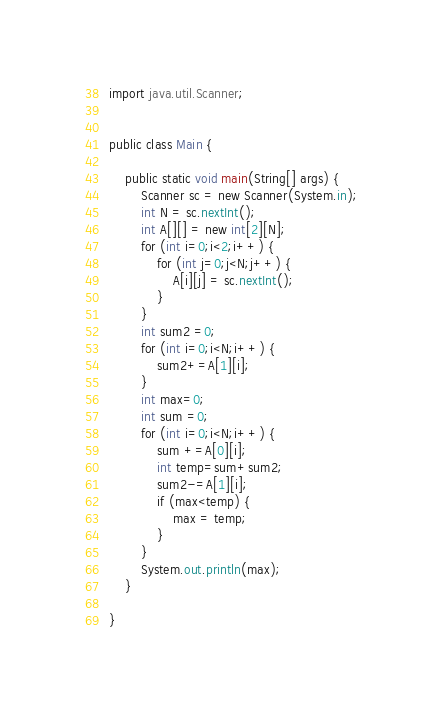Convert code to text. <code><loc_0><loc_0><loc_500><loc_500><_Java_>
import java.util.Scanner;


public class Main {

	public static void main(String[] args) {
		Scanner sc = new Scanner(System.in);
		int N = sc.nextInt();
		int A[][] = new int[2][N];
		for (int i=0;i<2;i++) {
			for (int j=0;j<N;j++) {
				A[i][j] = sc.nextInt();
			}
		}
		int sum2 =0;
		for (int i=0;i<N;i++) {
			sum2+=A[1][i];
		}
		int max=0;
		int sum =0;
		for (int i=0;i<N;i++) {
			sum +=A[0][i];
			int temp=sum+sum2;
			sum2-=A[1][i];
			if (max<temp) {
				max = temp;
			}
		}
		System.out.println(max);
	}

}</code> 